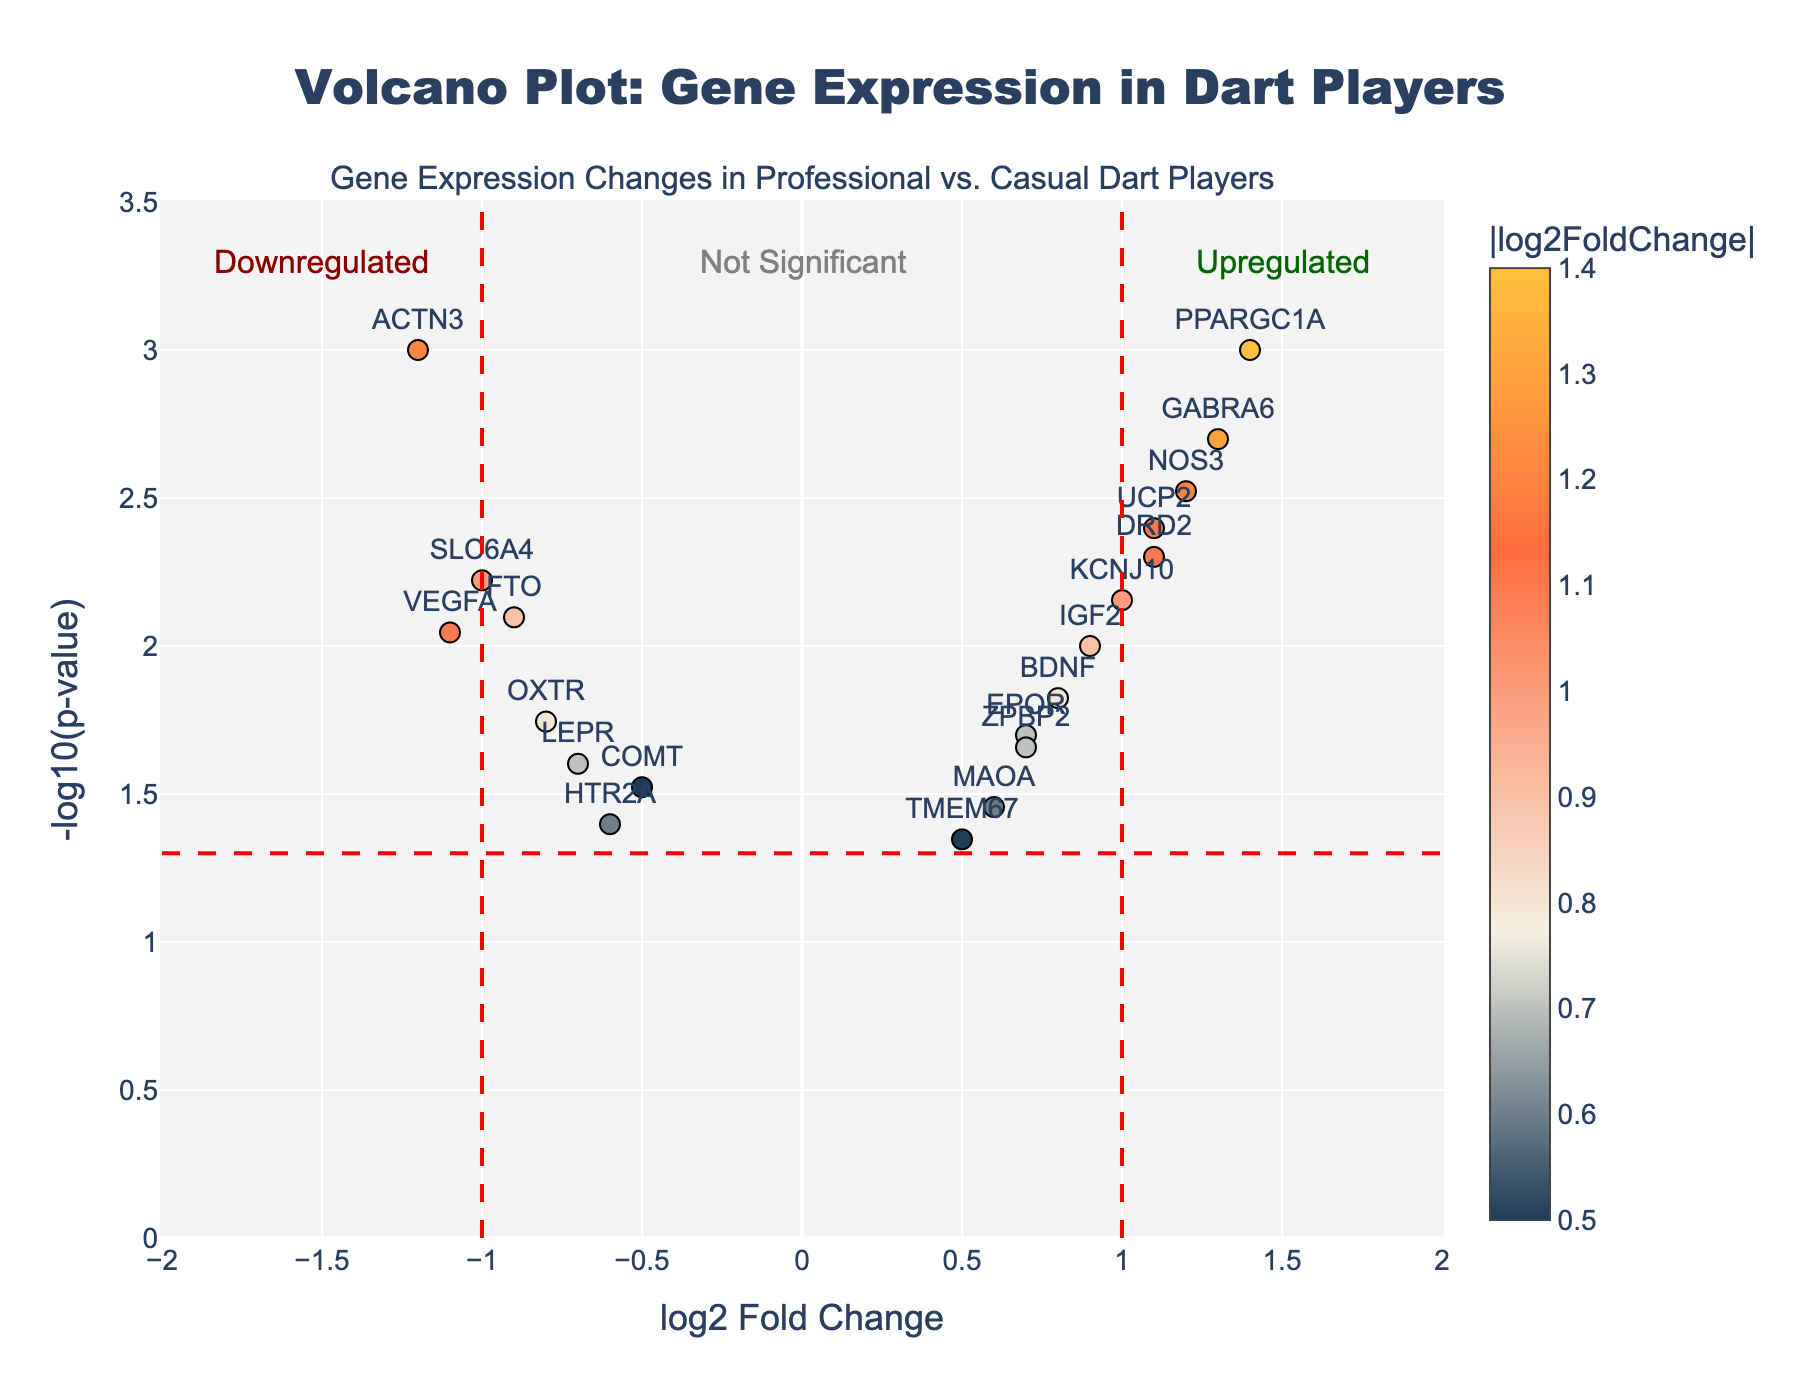How many genes show a significant upregulation? To determine the number of genes showing significant upregulation, look at the points on the right side (log2 Fold Change ≥ 1) with a high -log10(p-value) (above the horizontal threshold line). These genes have a log2FoldChange greater than 1 and a p-value lower than 0.05.
Answer: 5 Which gene has the highest -log10(p-value)? The highest -log10(p-value) indicates the most statistically significant gene. By examining the y-axis, GABRA6 is at the topmost position.
Answer: GABRA6 Are there more significantly downregulated genes or upregulated genes? Compare the number of genes left of the vertical threshold line at -1 and right of the threshold line at 1. Both conditions must be with a high -log10(p-value). Count the points on each side to determine which is more.
Answer: More upregulated What is the range of log2 Fold Change values present in the plot? The range can be found by looking at the minimum and maximum values on the x-axis. The extreme leftmost and rightmost points provide this information.
Answer: -1.4 to 1.4 How many genes are considered non-significant? Non-significant genes are below the horizontal threshold line marking a -log10(p-value) of 1.3. Count all the points below this line.
Answer: 8 Which gene is the highest upregulated with respect to log2 Fold Change? Find the point farthest to the right along the x-axis among the significant genes (above the thresholds). PPARGC1A is the rightmost point.
Answer: PPARGC1A Is there a gene that is significantly expressed but has a log2 Fold Change between -0.5 and 0.5? Check the vertical positions of points within the log2 Fold Change range -0.5 to 0.5 to see if any are above the threshold.
Answer: Yes, TMEM67 Which gene is closest to the center of the plot? The center of the plot is at (0, 0). Look for the point nearest to this coordinate. COMT is closest.
Answer: COMT Which gene has the lowest log2 Fold Change but is still statistically significant? The most downregulated significant gene will be on the far left, above the threshold. ACTN3 is the leftmost point.
Answer: ACTN3 